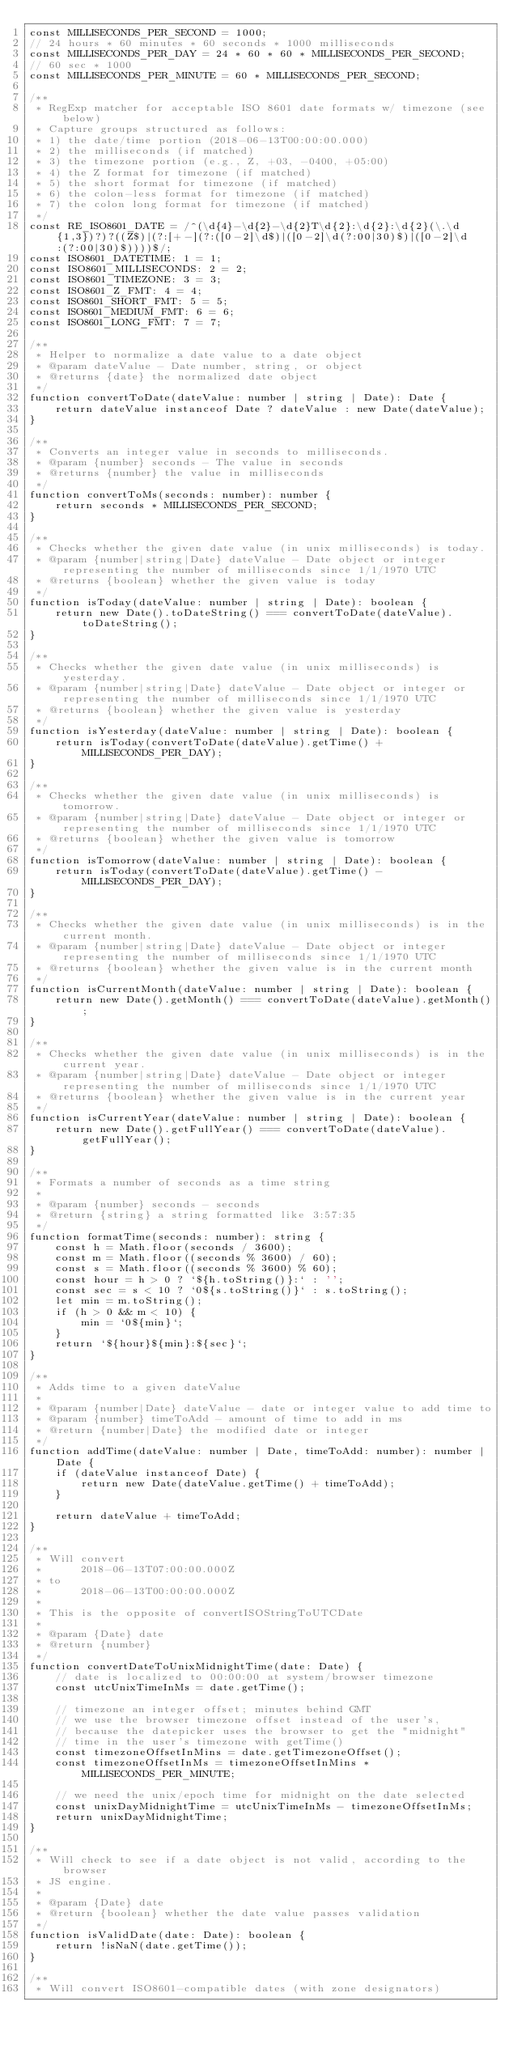Convert code to text. <code><loc_0><loc_0><loc_500><loc_500><_JavaScript_>const MILLISECONDS_PER_SECOND = 1000;
// 24 hours * 60 minutes * 60 seconds * 1000 milliseconds
const MILLISECONDS_PER_DAY = 24 * 60 * 60 * MILLISECONDS_PER_SECOND;
// 60 sec * 1000
const MILLISECONDS_PER_MINUTE = 60 * MILLISECONDS_PER_SECOND;

/**
 * RegExp matcher for acceptable ISO 8601 date formats w/ timezone (see below)
 * Capture groups structured as follows:
 * 1) the date/time portion (2018-06-13T00:00:00.000)
 * 2) the milliseconds (if matched)
 * 3) the timezone portion (e.g., Z, +03, -0400, +05:00)
 * 4) the Z format for timezone (if matched)
 * 5) the short format for timezone (if matched)
 * 6) the colon-less format for timezone (if matched)
 * 7) the colon long format for timezone (if matched)
 */
const RE_ISO8601_DATE = /^(\d{4}-\d{2}-\d{2}T\d{2}:\d{2}:\d{2}(\.\d{1,3})?)?((Z$)|(?:[+-](?:([0-2]\d$)|([0-2]\d(?:00|30)$)|([0-2]\d:(?:00|30)$))))$/;
const ISO8601_DATETIME: 1 = 1;
const ISO8601_MILLISECONDS: 2 = 2;
const ISO8601_TIMEZONE: 3 = 3;
const ISO8601_Z_FMT: 4 = 4;
const ISO8601_SHORT_FMT: 5 = 5;
const ISO8601_MEDIUM_FMT: 6 = 6;
const ISO8601_LONG_FMT: 7 = 7;

/**
 * Helper to normalize a date value to a date object
 * @param dateValue - Date number, string, or object
 * @returns {date} the normalized date object
 */
function convertToDate(dateValue: number | string | Date): Date {
    return dateValue instanceof Date ? dateValue : new Date(dateValue);
}

/**
 * Converts an integer value in seconds to milliseconds.
 * @param {number} seconds - The value in seconds
 * @returns {number} the value in milliseconds
 */
function convertToMs(seconds: number): number {
    return seconds * MILLISECONDS_PER_SECOND;
}

/**
 * Checks whether the given date value (in unix milliseconds) is today.
 * @param {number|string|Date} dateValue - Date object or integer representing the number of milliseconds since 1/1/1970 UTC
 * @returns {boolean} whether the given value is today
 */
function isToday(dateValue: number | string | Date): boolean {
    return new Date().toDateString() === convertToDate(dateValue).toDateString();
}

/**
 * Checks whether the given date value (in unix milliseconds) is yesterday.
 * @param {number|string|Date} dateValue - Date object or integer or representing the number of milliseconds since 1/1/1970 UTC
 * @returns {boolean} whether the given value is yesterday
 */
function isYesterday(dateValue: number | string | Date): boolean {
    return isToday(convertToDate(dateValue).getTime() + MILLISECONDS_PER_DAY);
}

/**
 * Checks whether the given date value (in unix milliseconds) is tomorrow.
 * @param {number|string|Date} dateValue - Date object or integer or representing the number of milliseconds since 1/1/1970 UTC
 * @returns {boolean} whether the given value is tomorrow
 */
function isTomorrow(dateValue: number | string | Date): boolean {
    return isToday(convertToDate(dateValue).getTime() - MILLISECONDS_PER_DAY);
}

/**
 * Checks whether the given date value (in unix milliseconds) is in the current month.
 * @param {number|string|Date} dateValue - Date object or integer representing the number of milliseconds since 1/1/1970 UTC
 * @returns {boolean} whether the given value is in the current month
 */
function isCurrentMonth(dateValue: number | string | Date): boolean {
    return new Date().getMonth() === convertToDate(dateValue).getMonth();
}

/**
 * Checks whether the given date value (in unix milliseconds) is in the current year.
 * @param {number|string|Date} dateValue - Date object or integer representing the number of milliseconds since 1/1/1970 UTC
 * @returns {boolean} whether the given value is in the current year
 */
function isCurrentYear(dateValue: number | string | Date): boolean {
    return new Date().getFullYear() === convertToDate(dateValue).getFullYear();
}

/**
 * Formats a number of seconds as a time string
 *
 * @param {number} seconds - seconds
 * @return {string} a string formatted like 3:57:35
 */
function formatTime(seconds: number): string {
    const h = Math.floor(seconds / 3600);
    const m = Math.floor((seconds % 3600) / 60);
    const s = Math.floor((seconds % 3600) % 60);
    const hour = h > 0 ? `${h.toString()}:` : '';
    const sec = s < 10 ? `0${s.toString()}` : s.toString();
    let min = m.toString();
    if (h > 0 && m < 10) {
        min = `0${min}`;
    }
    return `${hour}${min}:${sec}`;
}

/**
 * Adds time to a given dateValue
 *
 * @param {number|Date} dateValue - date or integer value to add time to
 * @param {number} timeToAdd - amount of time to add in ms
 * @return {number|Date} the modified date or integer
 */
function addTime(dateValue: number | Date, timeToAdd: number): number | Date {
    if (dateValue instanceof Date) {
        return new Date(dateValue.getTime() + timeToAdd);
    }

    return dateValue + timeToAdd;
}

/**
 * Will convert
 *      2018-06-13T07:00:00.000Z
 * to
 *      2018-06-13T00:00:00.000Z
 *
 * This is the opposite of convertISOStringToUTCDate
 *
 * @param {Date} date
 * @return {number}
 */
function convertDateToUnixMidnightTime(date: Date) {
    // date is localized to 00:00:00 at system/browser timezone
    const utcUnixTimeInMs = date.getTime();

    // timezone an integer offset; minutes behind GMT
    // we use the browser timezone offset instead of the user's,
    // because the datepicker uses the browser to get the "midnight"
    // time in the user's timezone with getTime()
    const timezoneOffsetInMins = date.getTimezoneOffset();
    const timezoneOffsetInMs = timezoneOffsetInMins * MILLISECONDS_PER_MINUTE;

    // we need the unix/epoch time for midnight on the date selected
    const unixDayMidnightTime = utcUnixTimeInMs - timezoneOffsetInMs;
    return unixDayMidnightTime;
}

/**
 * Will check to see if a date object is not valid, according to the browser
 * JS engine.
 *
 * @param {Date} date
 * @return {boolean} whether the date value passes validation
 */
function isValidDate(date: Date): boolean {
    return !isNaN(date.getTime());
}

/**
 * Will convert ISO8601-compatible dates (with zone designators)</code> 